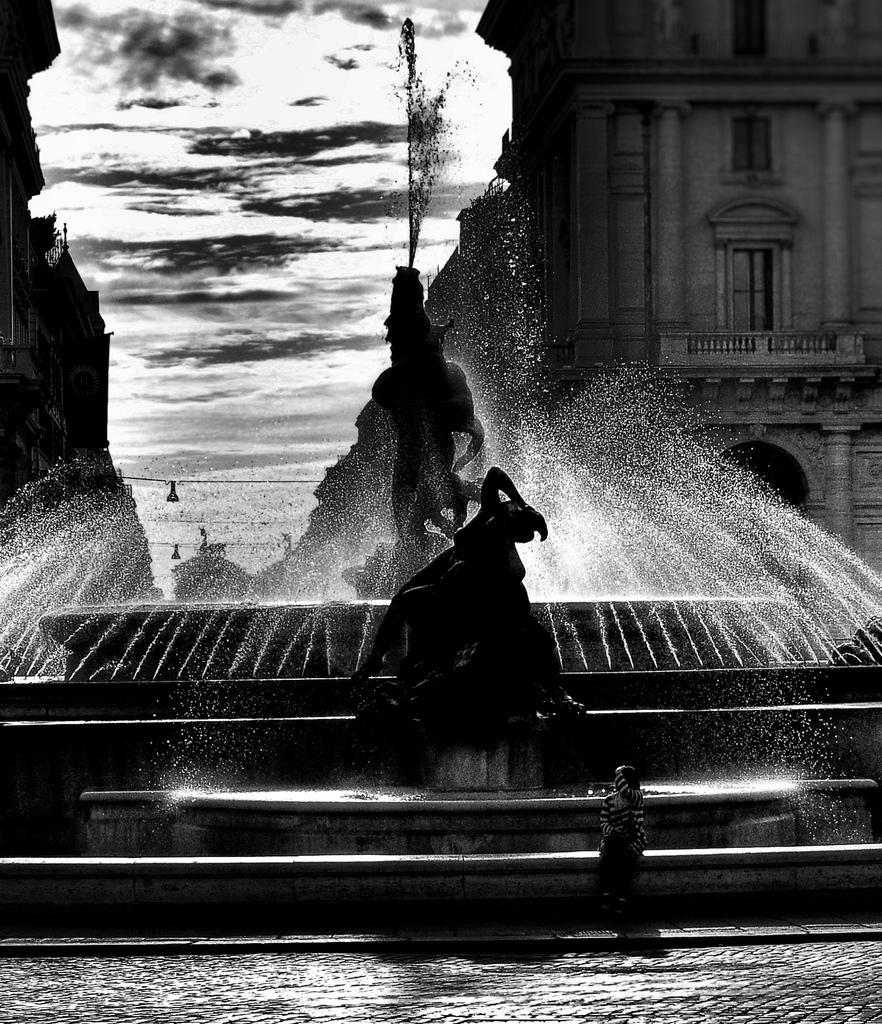How would you summarize this image in a sentence or two? In this image in the center there is a statue, and there is a fountain. At the bottom there is walkway and there is one women sitting on a wall, and in the background there are buildings. At the top there is sky. 